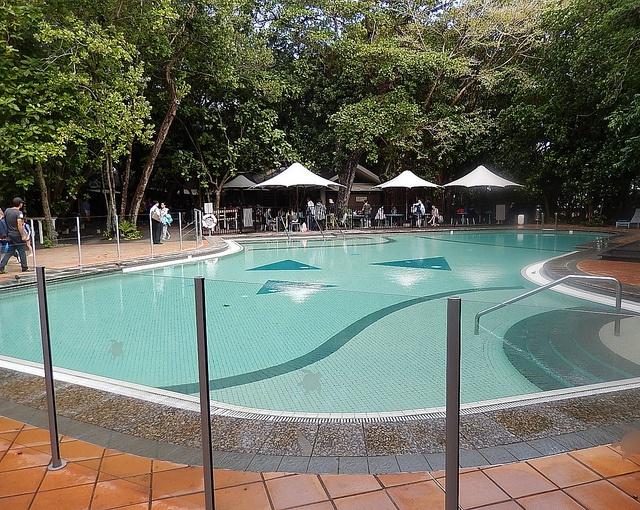Describe the objects in this image and their specific colors. I can see people in black, gray, and darkgray tones, umbrella in black, white, gray, and darkgray tones, umbrella in black, lightgray, gray, and darkgray tones, umbrella in black, white, darkgray, and gray tones, and people in black, white, darkgray, and gray tones in this image. 